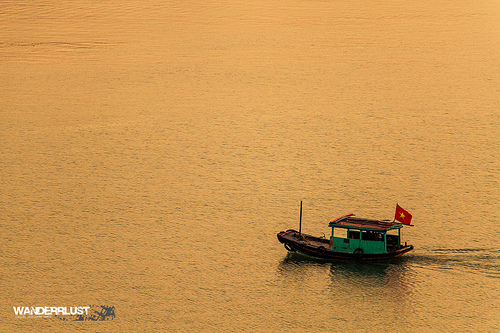<image>
Is there a flag in the water? No. The flag is not contained within the water. These objects have a different spatial relationship. 